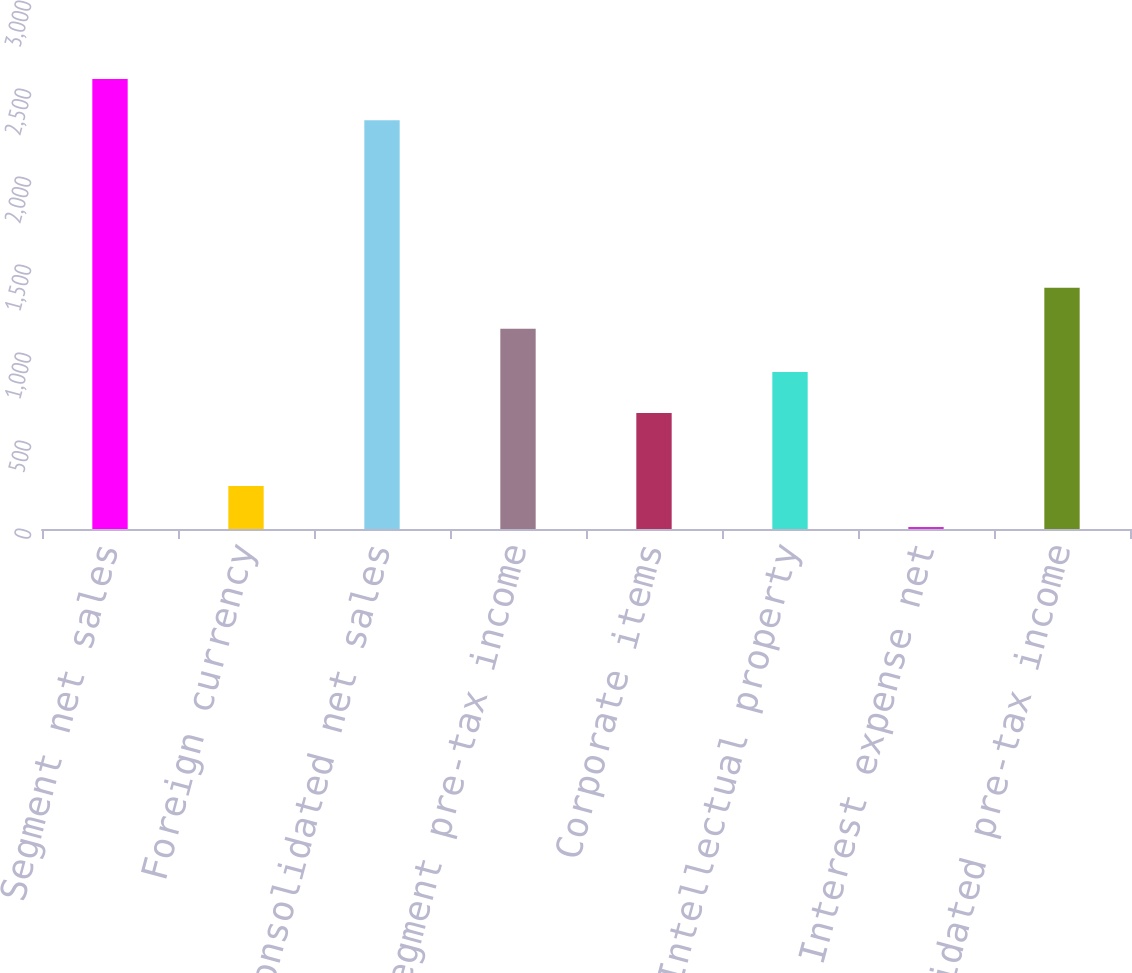<chart> <loc_0><loc_0><loc_500><loc_500><bar_chart><fcel>Segment net sales<fcel>Foreign currency<fcel>Consolidated net sales<fcel>Segment pre-tax income<fcel>Corporate items<fcel>Intellectual property<fcel>Interest expense net<fcel>Consolidated pre-tax income<nl><fcel>2556.28<fcel>244.18<fcel>2322.9<fcel>1137.5<fcel>659.2<fcel>892.58<fcel>10.8<fcel>1370.88<nl></chart> 